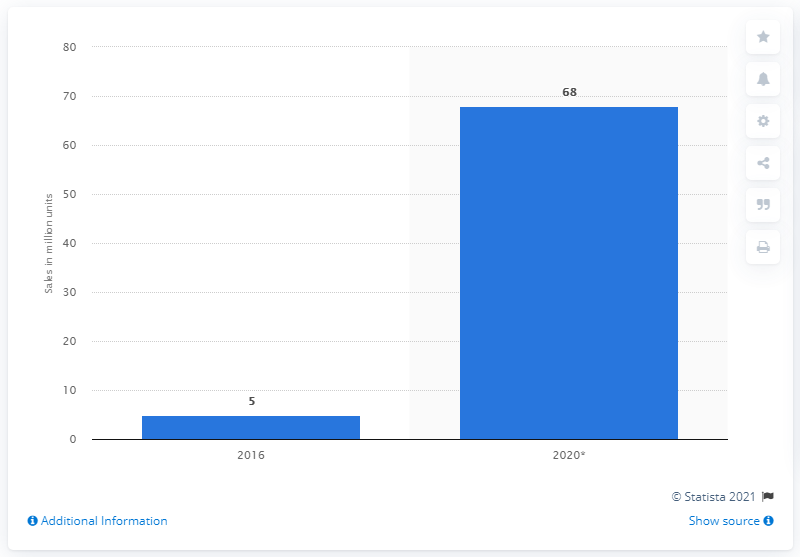Draw attention to some important aspects in this diagram. The global unit sales of head-mounted displays in 2016 were approximately 5. The forecast number of VR headset unit sales in 2020 is expected to be 68. 